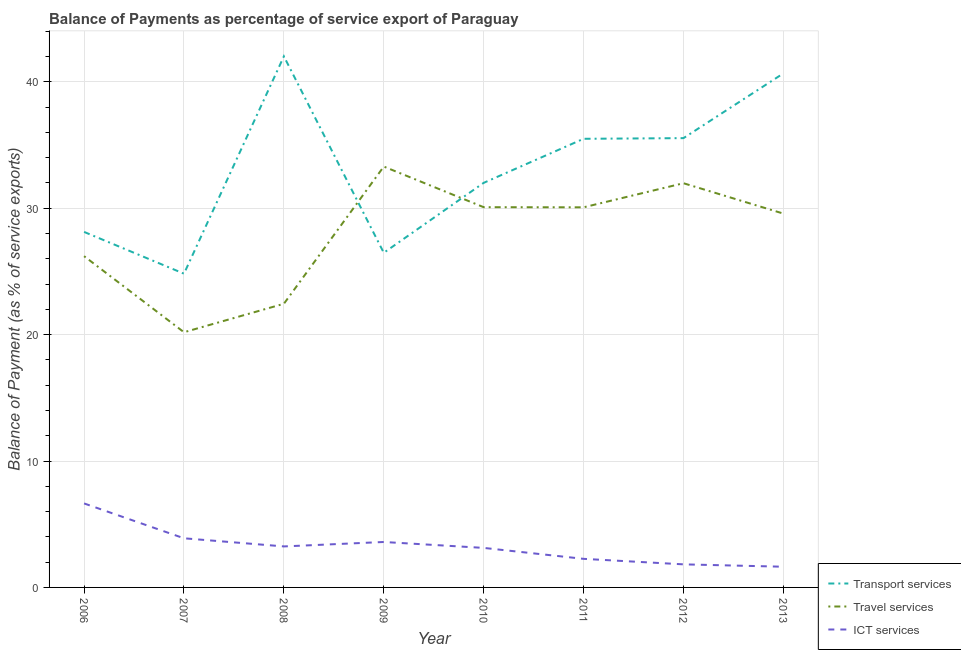Is the number of lines equal to the number of legend labels?
Make the answer very short. Yes. What is the balance of payment of ict services in 2011?
Ensure brevity in your answer.  2.26. Across all years, what is the maximum balance of payment of ict services?
Make the answer very short. 6.64. Across all years, what is the minimum balance of payment of travel services?
Your response must be concise. 20.19. What is the total balance of payment of ict services in the graph?
Your response must be concise. 26.22. What is the difference between the balance of payment of ict services in 2006 and that in 2011?
Your response must be concise. 4.38. What is the difference between the balance of payment of transport services in 2007 and the balance of payment of ict services in 2011?
Ensure brevity in your answer.  22.56. What is the average balance of payment of ict services per year?
Provide a short and direct response. 3.28. In the year 2010, what is the difference between the balance of payment of travel services and balance of payment of ict services?
Give a very brief answer. 26.96. In how many years, is the balance of payment of transport services greater than 10 %?
Your answer should be very brief. 8. What is the ratio of the balance of payment of ict services in 2012 to that in 2013?
Make the answer very short. 1.11. Is the balance of payment of ict services in 2008 less than that in 2010?
Give a very brief answer. No. What is the difference between the highest and the second highest balance of payment of travel services?
Your answer should be compact. 1.32. What is the difference between the highest and the lowest balance of payment of travel services?
Provide a succinct answer. 13.11. In how many years, is the balance of payment of transport services greater than the average balance of payment of transport services taken over all years?
Provide a succinct answer. 4. Is the sum of the balance of payment of ict services in 2008 and 2011 greater than the maximum balance of payment of travel services across all years?
Your answer should be compact. No. Is it the case that in every year, the sum of the balance of payment of transport services and balance of payment of travel services is greater than the balance of payment of ict services?
Offer a terse response. Yes. Does the balance of payment of travel services monotonically increase over the years?
Your answer should be compact. No. Does the graph contain any zero values?
Keep it short and to the point. No. What is the title of the graph?
Make the answer very short. Balance of Payments as percentage of service export of Paraguay. Does "Female employers" appear as one of the legend labels in the graph?
Offer a very short reply. No. What is the label or title of the X-axis?
Your response must be concise. Year. What is the label or title of the Y-axis?
Your answer should be compact. Balance of Payment (as % of service exports). What is the Balance of Payment (as % of service exports) of Transport services in 2006?
Offer a very short reply. 28.13. What is the Balance of Payment (as % of service exports) in Travel services in 2006?
Make the answer very short. 26.21. What is the Balance of Payment (as % of service exports) of ICT services in 2006?
Offer a terse response. 6.64. What is the Balance of Payment (as % of service exports) in Transport services in 2007?
Your response must be concise. 24.82. What is the Balance of Payment (as % of service exports) of Travel services in 2007?
Your response must be concise. 20.19. What is the Balance of Payment (as % of service exports) of ICT services in 2007?
Your answer should be compact. 3.89. What is the Balance of Payment (as % of service exports) of Transport services in 2008?
Keep it short and to the point. 42.02. What is the Balance of Payment (as % of service exports) in Travel services in 2008?
Keep it short and to the point. 22.44. What is the Balance of Payment (as % of service exports) in ICT services in 2008?
Your answer should be compact. 3.24. What is the Balance of Payment (as % of service exports) in Transport services in 2009?
Your answer should be compact. 26.48. What is the Balance of Payment (as % of service exports) of Travel services in 2009?
Provide a succinct answer. 33.3. What is the Balance of Payment (as % of service exports) in ICT services in 2009?
Give a very brief answer. 3.59. What is the Balance of Payment (as % of service exports) in Transport services in 2010?
Ensure brevity in your answer.  32.01. What is the Balance of Payment (as % of service exports) in Travel services in 2010?
Your answer should be very brief. 30.08. What is the Balance of Payment (as % of service exports) of ICT services in 2010?
Keep it short and to the point. 3.13. What is the Balance of Payment (as % of service exports) of Transport services in 2011?
Ensure brevity in your answer.  35.49. What is the Balance of Payment (as % of service exports) in Travel services in 2011?
Offer a terse response. 30.07. What is the Balance of Payment (as % of service exports) of ICT services in 2011?
Make the answer very short. 2.26. What is the Balance of Payment (as % of service exports) of Transport services in 2012?
Provide a succinct answer. 35.55. What is the Balance of Payment (as % of service exports) in Travel services in 2012?
Make the answer very short. 31.98. What is the Balance of Payment (as % of service exports) of ICT services in 2012?
Provide a short and direct response. 1.83. What is the Balance of Payment (as % of service exports) in Transport services in 2013?
Make the answer very short. 40.67. What is the Balance of Payment (as % of service exports) in Travel services in 2013?
Ensure brevity in your answer.  29.58. What is the Balance of Payment (as % of service exports) of ICT services in 2013?
Keep it short and to the point. 1.64. Across all years, what is the maximum Balance of Payment (as % of service exports) in Transport services?
Make the answer very short. 42.02. Across all years, what is the maximum Balance of Payment (as % of service exports) of Travel services?
Make the answer very short. 33.3. Across all years, what is the maximum Balance of Payment (as % of service exports) in ICT services?
Offer a very short reply. 6.64. Across all years, what is the minimum Balance of Payment (as % of service exports) of Transport services?
Make the answer very short. 24.82. Across all years, what is the minimum Balance of Payment (as % of service exports) in Travel services?
Your response must be concise. 20.19. Across all years, what is the minimum Balance of Payment (as % of service exports) in ICT services?
Keep it short and to the point. 1.64. What is the total Balance of Payment (as % of service exports) in Transport services in the graph?
Provide a succinct answer. 265.16. What is the total Balance of Payment (as % of service exports) in Travel services in the graph?
Provide a short and direct response. 223.85. What is the total Balance of Payment (as % of service exports) of ICT services in the graph?
Provide a short and direct response. 26.22. What is the difference between the Balance of Payment (as % of service exports) of Transport services in 2006 and that in 2007?
Ensure brevity in your answer.  3.31. What is the difference between the Balance of Payment (as % of service exports) in Travel services in 2006 and that in 2007?
Your response must be concise. 6.02. What is the difference between the Balance of Payment (as % of service exports) of ICT services in 2006 and that in 2007?
Ensure brevity in your answer.  2.76. What is the difference between the Balance of Payment (as % of service exports) in Transport services in 2006 and that in 2008?
Provide a succinct answer. -13.89. What is the difference between the Balance of Payment (as % of service exports) in Travel services in 2006 and that in 2008?
Keep it short and to the point. 3.77. What is the difference between the Balance of Payment (as % of service exports) of ICT services in 2006 and that in 2008?
Your answer should be very brief. 3.4. What is the difference between the Balance of Payment (as % of service exports) of Transport services in 2006 and that in 2009?
Give a very brief answer. 1.65. What is the difference between the Balance of Payment (as % of service exports) of Travel services in 2006 and that in 2009?
Your answer should be compact. -7.09. What is the difference between the Balance of Payment (as % of service exports) of ICT services in 2006 and that in 2009?
Provide a short and direct response. 3.05. What is the difference between the Balance of Payment (as % of service exports) of Transport services in 2006 and that in 2010?
Provide a succinct answer. -3.88. What is the difference between the Balance of Payment (as % of service exports) of Travel services in 2006 and that in 2010?
Provide a succinct answer. -3.88. What is the difference between the Balance of Payment (as % of service exports) of ICT services in 2006 and that in 2010?
Keep it short and to the point. 3.52. What is the difference between the Balance of Payment (as % of service exports) of Transport services in 2006 and that in 2011?
Provide a short and direct response. -7.37. What is the difference between the Balance of Payment (as % of service exports) of Travel services in 2006 and that in 2011?
Your response must be concise. -3.87. What is the difference between the Balance of Payment (as % of service exports) in ICT services in 2006 and that in 2011?
Provide a succinct answer. 4.38. What is the difference between the Balance of Payment (as % of service exports) of Transport services in 2006 and that in 2012?
Offer a very short reply. -7.42. What is the difference between the Balance of Payment (as % of service exports) in Travel services in 2006 and that in 2012?
Keep it short and to the point. -5.77. What is the difference between the Balance of Payment (as % of service exports) in ICT services in 2006 and that in 2012?
Your response must be concise. 4.82. What is the difference between the Balance of Payment (as % of service exports) in Transport services in 2006 and that in 2013?
Give a very brief answer. -12.54. What is the difference between the Balance of Payment (as % of service exports) of Travel services in 2006 and that in 2013?
Your answer should be compact. -3.37. What is the difference between the Balance of Payment (as % of service exports) in ICT services in 2006 and that in 2013?
Make the answer very short. 5.01. What is the difference between the Balance of Payment (as % of service exports) of Transport services in 2007 and that in 2008?
Ensure brevity in your answer.  -17.2. What is the difference between the Balance of Payment (as % of service exports) in Travel services in 2007 and that in 2008?
Ensure brevity in your answer.  -2.25. What is the difference between the Balance of Payment (as % of service exports) in ICT services in 2007 and that in 2008?
Your response must be concise. 0.64. What is the difference between the Balance of Payment (as % of service exports) in Transport services in 2007 and that in 2009?
Your answer should be very brief. -1.65. What is the difference between the Balance of Payment (as % of service exports) of Travel services in 2007 and that in 2009?
Your answer should be compact. -13.11. What is the difference between the Balance of Payment (as % of service exports) in ICT services in 2007 and that in 2009?
Keep it short and to the point. 0.29. What is the difference between the Balance of Payment (as % of service exports) in Transport services in 2007 and that in 2010?
Offer a very short reply. -7.19. What is the difference between the Balance of Payment (as % of service exports) in Travel services in 2007 and that in 2010?
Provide a succinct answer. -9.89. What is the difference between the Balance of Payment (as % of service exports) in ICT services in 2007 and that in 2010?
Your response must be concise. 0.76. What is the difference between the Balance of Payment (as % of service exports) of Transport services in 2007 and that in 2011?
Provide a succinct answer. -10.67. What is the difference between the Balance of Payment (as % of service exports) in Travel services in 2007 and that in 2011?
Provide a short and direct response. -9.88. What is the difference between the Balance of Payment (as % of service exports) in ICT services in 2007 and that in 2011?
Keep it short and to the point. 1.63. What is the difference between the Balance of Payment (as % of service exports) in Transport services in 2007 and that in 2012?
Keep it short and to the point. -10.72. What is the difference between the Balance of Payment (as % of service exports) in Travel services in 2007 and that in 2012?
Keep it short and to the point. -11.79. What is the difference between the Balance of Payment (as % of service exports) in ICT services in 2007 and that in 2012?
Give a very brief answer. 2.06. What is the difference between the Balance of Payment (as % of service exports) in Transport services in 2007 and that in 2013?
Make the answer very short. -15.85. What is the difference between the Balance of Payment (as % of service exports) in Travel services in 2007 and that in 2013?
Offer a terse response. -9.39. What is the difference between the Balance of Payment (as % of service exports) in ICT services in 2007 and that in 2013?
Provide a short and direct response. 2.25. What is the difference between the Balance of Payment (as % of service exports) of Transport services in 2008 and that in 2009?
Make the answer very short. 15.54. What is the difference between the Balance of Payment (as % of service exports) in Travel services in 2008 and that in 2009?
Your answer should be very brief. -10.86. What is the difference between the Balance of Payment (as % of service exports) in ICT services in 2008 and that in 2009?
Offer a terse response. -0.35. What is the difference between the Balance of Payment (as % of service exports) of Transport services in 2008 and that in 2010?
Your answer should be compact. 10.01. What is the difference between the Balance of Payment (as % of service exports) of Travel services in 2008 and that in 2010?
Your response must be concise. -7.64. What is the difference between the Balance of Payment (as % of service exports) in ICT services in 2008 and that in 2010?
Keep it short and to the point. 0.12. What is the difference between the Balance of Payment (as % of service exports) of Transport services in 2008 and that in 2011?
Provide a succinct answer. 6.52. What is the difference between the Balance of Payment (as % of service exports) in Travel services in 2008 and that in 2011?
Offer a terse response. -7.63. What is the difference between the Balance of Payment (as % of service exports) of ICT services in 2008 and that in 2011?
Your response must be concise. 0.98. What is the difference between the Balance of Payment (as % of service exports) of Transport services in 2008 and that in 2012?
Provide a short and direct response. 6.47. What is the difference between the Balance of Payment (as % of service exports) in Travel services in 2008 and that in 2012?
Ensure brevity in your answer.  -9.54. What is the difference between the Balance of Payment (as % of service exports) of ICT services in 2008 and that in 2012?
Keep it short and to the point. 1.42. What is the difference between the Balance of Payment (as % of service exports) of Transport services in 2008 and that in 2013?
Keep it short and to the point. 1.35. What is the difference between the Balance of Payment (as % of service exports) of Travel services in 2008 and that in 2013?
Offer a terse response. -7.13. What is the difference between the Balance of Payment (as % of service exports) in ICT services in 2008 and that in 2013?
Ensure brevity in your answer.  1.61. What is the difference between the Balance of Payment (as % of service exports) of Transport services in 2009 and that in 2010?
Provide a short and direct response. -5.53. What is the difference between the Balance of Payment (as % of service exports) of Travel services in 2009 and that in 2010?
Provide a short and direct response. 3.21. What is the difference between the Balance of Payment (as % of service exports) in ICT services in 2009 and that in 2010?
Keep it short and to the point. 0.47. What is the difference between the Balance of Payment (as % of service exports) in Transport services in 2009 and that in 2011?
Provide a short and direct response. -9.02. What is the difference between the Balance of Payment (as % of service exports) of Travel services in 2009 and that in 2011?
Your answer should be very brief. 3.23. What is the difference between the Balance of Payment (as % of service exports) in ICT services in 2009 and that in 2011?
Your response must be concise. 1.33. What is the difference between the Balance of Payment (as % of service exports) in Transport services in 2009 and that in 2012?
Provide a short and direct response. -9.07. What is the difference between the Balance of Payment (as % of service exports) in Travel services in 2009 and that in 2012?
Ensure brevity in your answer.  1.32. What is the difference between the Balance of Payment (as % of service exports) of ICT services in 2009 and that in 2012?
Your answer should be very brief. 1.77. What is the difference between the Balance of Payment (as % of service exports) in Transport services in 2009 and that in 2013?
Ensure brevity in your answer.  -14.19. What is the difference between the Balance of Payment (as % of service exports) of Travel services in 2009 and that in 2013?
Your response must be concise. 3.72. What is the difference between the Balance of Payment (as % of service exports) of ICT services in 2009 and that in 2013?
Your response must be concise. 1.96. What is the difference between the Balance of Payment (as % of service exports) of Transport services in 2010 and that in 2011?
Give a very brief answer. -3.49. What is the difference between the Balance of Payment (as % of service exports) of Travel services in 2010 and that in 2011?
Give a very brief answer. 0.01. What is the difference between the Balance of Payment (as % of service exports) in ICT services in 2010 and that in 2011?
Keep it short and to the point. 0.87. What is the difference between the Balance of Payment (as % of service exports) of Transport services in 2010 and that in 2012?
Your answer should be very brief. -3.54. What is the difference between the Balance of Payment (as % of service exports) of Travel services in 2010 and that in 2012?
Your answer should be very brief. -1.9. What is the difference between the Balance of Payment (as % of service exports) of ICT services in 2010 and that in 2012?
Your answer should be very brief. 1.3. What is the difference between the Balance of Payment (as % of service exports) of Transport services in 2010 and that in 2013?
Your answer should be compact. -8.66. What is the difference between the Balance of Payment (as % of service exports) of Travel services in 2010 and that in 2013?
Offer a very short reply. 0.51. What is the difference between the Balance of Payment (as % of service exports) of ICT services in 2010 and that in 2013?
Ensure brevity in your answer.  1.49. What is the difference between the Balance of Payment (as % of service exports) in Transport services in 2011 and that in 2012?
Provide a short and direct response. -0.05. What is the difference between the Balance of Payment (as % of service exports) of Travel services in 2011 and that in 2012?
Give a very brief answer. -1.91. What is the difference between the Balance of Payment (as % of service exports) of ICT services in 2011 and that in 2012?
Ensure brevity in your answer.  0.44. What is the difference between the Balance of Payment (as % of service exports) in Transport services in 2011 and that in 2013?
Provide a succinct answer. -5.17. What is the difference between the Balance of Payment (as % of service exports) of Travel services in 2011 and that in 2013?
Your response must be concise. 0.5. What is the difference between the Balance of Payment (as % of service exports) in ICT services in 2011 and that in 2013?
Your response must be concise. 0.62. What is the difference between the Balance of Payment (as % of service exports) of Transport services in 2012 and that in 2013?
Offer a terse response. -5.12. What is the difference between the Balance of Payment (as % of service exports) in Travel services in 2012 and that in 2013?
Keep it short and to the point. 2.4. What is the difference between the Balance of Payment (as % of service exports) of ICT services in 2012 and that in 2013?
Offer a very short reply. 0.19. What is the difference between the Balance of Payment (as % of service exports) of Transport services in 2006 and the Balance of Payment (as % of service exports) of Travel services in 2007?
Provide a short and direct response. 7.94. What is the difference between the Balance of Payment (as % of service exports) of Transport services in 2006 and the Balance of Payment (as % of service exports) of ICT services in 2007?
Give a very brief answer. 24.24. What is the difference between the Balance of Payment (as % of service exports) in Travel services in 2006 and the Balance of Payment (as % of service exports) in ICT services in 2007?
Ensure brevity in your answer.  22.32. What is the difference between the Balance of Payment (as % of service exports) in Transport services in 2006 and the Balance of Payment (as % of service exports) in Travel services in 2008?
Ensure brevity in your answer.  5.69. What is the difference between the Balance of Payment (as % of service exports) in Transport services in 2006 and the Balance of Payment (as % of service exports) in ICT services in 2008?
Make the answer very short. 24.88. What is the difference between the Balance of Payment (as % of service exports) in Travel services in 2006 and the Balance of Payment (as % of service exports) in ICT services in 2008?
Your answer should be compact. 22.96. What is the difference between the Balance of Payment (as % of service exports) in Transport services in 2006 and the Balance of Payment (as % of service exports) in Travel services in 2009?
Your answer should be compact. -5.17. What is the difference between the Balance of Payment (as % of service exports) in Transport services in 2006 and the Balance of Payment (as % of service exports) in ICT services in 2009?
Your response must be concise. 24.53. What is the difference between the Balance of Payment (as % of service exports) in Travel services in 2006 and the Balance of Payment (as % of service exports) in ICT services in 2009?
Your response must be concise. 22.61. What is the difference between the Balance of Payment (as % of service exports) of Transport services in 2006 and the Balance of Payment (as % of service exports) of Travel services in 2010?
Keep it short and to the point. -1.96. What is the difference between the Balance of Payment (as % of service exports) in Transport services in 2006 and the Balance of Payment (as % of service exports) in ICT services in 2010?
Your answer should be compact. 25. What is the difference between the Balance of Payment (as % of service exports) of Travel services in 2006 and the Balance of Payment (as % of service exports) of ICT services in 2010?
Make the answer very short. 23.08. What is the difference between the Balance of Payment (as % of service exports) of Transport services in 2006 and the Balance of Payment (as % of service exports) of Travel services in 2011?
Keep it short and to the point. -1.95. What is the difference between the Balance of Payment (as % of service exports) in Transport services in 2006 and the Balance of Payment (as % of service exports) in ICT services in 2011?
Your answer should be very brief. 25.87. What is the difference between the Balance of Payment (as % of service exports) in Travel services in 2006 and the Balance of Payment (as % of service exports) in ICT services in 2011?
Offer a very short reply. 23.95. What is the difference between the Balance of Payment (as % of service exports) in Transport services in 2006 and the Balance of Payment (as % of service exports) in Travel services in 2012?
Provide a short and direct response. -3.85. What is the difference between the Balance of Payment (as % of service exports) in Transport services in 2006 and the Balance of Payment (as % of service exports) in ICT services in 2012?
Offer a terse response. 26.3. What is the difference between the Balance of Payment (as % of service exports) in Travel services in 2006 and the Balance of Payment (as % of service exports) in ICT services in 2012?
Offer a very short reply. 24.38. What is the difference between the Balance of Payment (as % of service exports) of Transport services in 2006 and the Balance of Payment (as % of service exports) of Travel services in 2013?
Your response must be concise. -1.45. What is the difference between the Balance of Payment (as % of service exports) of Transport services in 2006 and the Balance of Payment (as % of service exports) of ICT services in 2013?
Provide a succinct answer. 26.49. What is the difference between the Balance of Payment (as % of service exports) in Travel services in 2006 and the Balance of Payment (as % of service exports) in ICT services in 2013?
Your answer should be very brief. 24.57. What is the difference between the Balance of Payment (as % of service exports) in Transport services in 2007 and the Balance of Payment (as % of service exports) in Travel services in 2008?
Give a very brief answer. 2.38. What is the difference between the Balance of Payment (as % of service exports) in Transport services in 2007 and the Balance of Payment (as % of service exports) in ICT services in 2008?
Keep it short and to the point. 21.58. What is the difference between the Balance of Payment (as % of service exports) of Travel services in 2007 and the Balance of Payment (as % of service exports) of ICT services in 2008?
Keep it short and to the point. 16.95. What is the difference between the Balance of Payment (as % of service exports) of Transport services in 2007 and the Balance of Payment (as % of service exports) of Travel services in 2009?
Your answer should be very brief. -8.48. What is the difference between the Balance of Payment (as % of service exports) in Transport services in 2007 and the Balance of Payment (as % of service exports) in ICT services in 2009?
Offer a terse response. 21.23. What is the difference between the Balance of Payment (as % of service exports) in Travel services in 2007 and the Balance of Payment (as % of service exports) in ICT services in 2009?
Give a very brief answer. 16.6. What is the difference between the Balance of Payment (as % of service exports) of Transport services in 2007 and the Balance of Payment (as % of service exports) of Travel services in 2010?
Make the answer very short. -5.26. What is the difference between the Balance of Payment (as % of service exports) in Transport services in 2007 and the Balance of Payment (as % of service exports) in ICT services in 2010?
Make the answer very short. 21.69. What is the difference between the Balance of Payment (as % of service exports) of Travel services in 2007 and the Balance of Payment (as % of service exports) of ICT services in 2010?
Your response must be concise. 17.06. What is the difference between the Balance of Payment (as % of service exports) of Transport services in 2007 and the Balance of Payment (as % of service exports) of Travel services in 2011?
Keep it short and to the point. -5.25. What is the difference between the Balance of Payment (as % of service exports) in Transport services in 2007 and the Balance of Payment (as % of service exports) in ICT services in 2011?
Your answer should be very brief. 22.56. What is the difference between the Balance of Payment (as % of service exports) in Travel services in 2007 and the Balance of Payment (as % of service exports) in ICT services in 2011?
Your answer should be very brief. 17.93. What is the difference between the Balance of Payment (as % of service exports) in Transport services in 2007 and the Balance of Payment (as % of service exports) in Travel services in 2012?
Provide a succinct answer. -7.16. What is the difference between the Balance of Payment (as % of service exports) in Transport services in 2007 and the Balance of Payment (as % of service exports) in ICT services in 2012?
Offer a very short reply. 23. What is the difference between the Balance of Payment (as % of service exports) in Travel services in 2007 and the Balance of Payment (as % of service exports) in ICT services in 2012?
Keep it short and to the point. 18.36. What is the difference between the Balance of Payment (as % of service exports) of Transport services in 2007 and the Balance of Payment (as % of service exports) of Travel services in 2013?
Make the answer very short. -4.75. What is the difference between the Balance of Payment (as % of service exports) of Transport services in 2007 and the Balance of Payment (as % of service exports) of ICT services in 2013?
Provide a short and direct response. 23.18. What is the difference between the Balance of Payment (as % of service exports) of Travel services in 2007 and the Balance of Payment (as % of service exports) of ICT services in 2013?
Your response must be concise. 18.55. What is the difference between the Balance of Payment (as % of service exports) in Transport services in 2008 and the Balance of Payment (as % of service exports) in Travel services in 2009?
Offer a very short reply. 8.72. What is the difference between the Balance of Payment (as % of service exports) in Transport services in 2008 and the Balance of Payment (as % of service exports) in ICT services in 2009?
Your answer should be very brief. 38.42. What is the difference between the Balance of Payment (as % of service exports) in Travel services in 2008 and the Balance of Payment (as % of service exports) in ICT services in 2009?
Keep it short and to the point. 18.85. What is the difference between the Balance of Payment (as % of service exports) of Transport services in 2008 and the Balance of Payment (as % of service exports) of Travel services in 2010?
Give a very brief answer. 11.93. What is the difference between the Balance of Payment (as % of service exports) of Transport services in 2008 and the Balance of Payment (as % of service exports) of ICT services in 2010?
Offer a terse response. 38.89. What is the difference between the Balance of Payment (as % of service exports) in Travel services in 2008 and the Balance of Payment (as % of service exports) in ICT services in 2010?
Ensure brevity in your answer.  19.31. What is the difference between the Balance of Payment (as % of service exports) of Transport services in 2008 and the Balance of Payment (as % of service exports) of Travel services in 2011?
Provide a short and direct response. 11.94. What is the difference between the Balance of Payment (as % of service exports) in Transport services in 2008 and the Balance of Payment (as % of service exports) in ICT services in 2011?
Keep it short and to the point. 39.76. What is the difference between the Balance of Payment (as % of service exports) of Travel services in 2008 and the Balance of Payment (as % of service exports) of ICT services in 2011?
Give a very brief answer. 20.18. What is the difference between the Balance of Payment (as % of service exports) in Transport services in 2008 and the Balance of Payment (as % of service exports) in Travel services in 2012?
Provide a short and direct response. 10.04. What is the difference between the Balance of Payment (as % of service exports) of Transport services in 2008 and the Balance of Payment (as % of service exports) of ICT services in 2012?
Your response must be concise. 40.19. What is the difference between the Balance of Payment (as % of service exports) in Travel services in 2008 and the Balance of Payment (as % of service exports) in ICT services in 2012?
Keep it short and to the point. 20.62. What is the difference between the Balance of Payment (as % of service exports) in Transport services in 2008 and the Balance of Payment (as % of service exports) in Travel services in 2013?
Keep it short and to the point. 12.44. What is the difference between the Balance of Payment (as % of service exports) of Transport services in 2008 and the Balance of Payment (as % of service exports) of ICT services in 2013?
Your answer should be compact. 40.38. What is the difference between the Balance of Payment (as % of service exports) of Travel services in 2008 and the Balance of Payment (as % of service exports) of ICT services in 2013?
Keep it short and to the point. 20.8. What is the difference between the Balance of Payment (as % of service exports) in Transport services in 2009 and the Balance of Payment (as % of service exports) in Travel services in 2010?
Offer a terse response. -3.61. What is the difference between the Balance of Payment (as % of service exports) in Transport services in 2009 and the Balance of Payment (as % of service exports) in ICT services in 2010?
Provide a succinct answer. 23.35. What is the difference between the Balance of Payment (as % of service exports) of Travel services in 2009 and the Balance of Payment (as % of service exports) of ICT services in 2010?
Your answer should be compact. 30.17. What is the difference between the Balance of Payment (as % of service exports) in Transport services in 2009 and the Balance of Payment (as % of service exports) in Travel services in 2011?
Your answer should be compact. -3.6. What is the difference between the Balance of Payment (as % of service exports) of Transport services in 2009 and the Balance of Payment (as % of service exports) of ICT services in 2011?
Keep it short and to the point. 24.21. What is the difference between the Balance of Payment (as % of service exports) in Travel services in 2009 and the Balance of Payment (as % of service exports) in ICT services in 2011?
Your response must be concise. 31.04. What is the difference between the Balance of Payment (as % of service exports) of Transport services in 2009 and the Balance of Payment (as % of service exports) of Travel services in 2012?
Make the answer very short. -5.5. What is the difference between the Balance of Payment (as % of service exports) in Transport services in 2009 and the Balance of Payment (as % of service exports) in ICT services in 2012?
Offer a terse response. 24.65. What is the difference between the Balance of Payment (as % of service exports) in Travel services in 2009 and the Balance of Payment (as % of service exports) in ICT services in 2012?
Offer a very short reply. 31.47. What is the difference between the Balance of Payment (as % of service exports) of Transport services in 2009 and the Balance of Payment (as % of service exports) of Travel services in 2013?
Provide a succinct answer. -3.1. What is the difference between the Balance of Payment (as % of service exports) in Transport services in 2009 and the Balance of Payment (as % of service exports) in ICT services in 2013?
Provide a short and direct response. 24.84. What is the difference between the Balance of Payment (as % of service exports) in Travel services in 2009 and the Balance of Payment (as % of service exports) in ICT services in 2013?
Ensure brevity in your answer.  31.66. What is the difference between the Balance of Payment (as % of service exports) in Transport services in 2010 and the Balance of Payment (as % of service exports) in Travel services in 2011?
Your answer should be compact. 1.94. What is the difference between the Balance of Payment (as % of service exports) in Transport services in 2010 and the Balance of Payment (as % of service exports) in ICT services in 2011?
Ensure brevity in your answer.  29.75. What is the difference between the Balance of Payment (as % of service exports) of Travel services in 2010 and the Balance of Payment (as % of service exports) of ICT services in 2011?
Ensure brevity in your answer.  27.82. What is the difference between the Balance of Payment (as % of service exports) in Transport services in 2010 and the Balance of Payment (as % of service exports) in ICT services in 2012?
Keep it short and to the point. 30.18. What is the difference between the Balance of Payment (as % of service exports) of Travel services in 2010 and the Balance of Payment (as % of service exports) of ICT services in 2012?
Your response must be concise. 28.26. What is the difference between the Balance of Payment (as % of service exports) of Transport services in 2010 and the Balance of Payment (as % of service exports) of Travel services in 2013?
Your answer should be compact. 2.43. What is the difference between the Balance of Payment (as % of service exports) in Transport services in 2010 and the Balance of Payment (as % of service exports) in ICT services in 2013?
Make the answer very short. 30.37. What is the difference between the Balance of Payment (as % of service exports) of Travel services in 2010 and the Balance of Payment (as % of service exports) of ICT services in 2013?
Provide a succinct answer. 28.45. What is the difference between the Balance of Payment (as % of service exports) in Transport services in 2011 and the Balance of Payment (as % of service exports) in Travel services in 2012?
Keep it short and to the point. 3.52. What is the difference between the Balance of Payment (as % of service exports) of Transport services in 2011 and the Balance of Payment (as % of service exports) of ICT services in 2012?
Provide a succinct answer. 33.67. What is the difference between the Balance of Payment (as % of service exports) of Travel services in 2011 and the Balance of Payment (as % of service exports) of ICT services in 2012?
Your response must be concise. 28.25. What is the difference between the Balance of Payment (as % of service exports) of Transport services in 2011 and the Balance of Payment (as % of service exports) of Travel services in 2013?
Keep it short and to the point. 5.92. What is the difference between the Balance of Payment (as % of service exports) of Transport services in 2011 and the Balance of Payment (as % of service exports) of ICT services in 2013?
Your response must be concise. 33.86. What is the difference between the Balance of Payment (as % of service exports) of Travel services in 2011 and the Balance of Payment (as % of service exports) of ICT services in 2013?
Give a very brief answer. 28.43. What is the difference between the Balance of Payment (as % of service exports) in Transport services in 2012 and the Balance of Payment (as % of service exports) in Travel services in 2013?
Provide a succinct answer. 5.97. What is the difference between the Balance of Payment (as % of service exports) of Transport services in 2012 and the Balance of Payment (as % of service exports) of ICT services in 2013?
Give a very brief answer. 33.91. What is the difference between the Balance of Payment (as % of service exports) of Travel services in 2012 and the Balance of Payment (as % of service exports) of ICT services in 2013?
Your response must be concise. 30.34. What is the average Balance of Payment (as % of service exports) in Transport services per year?
Give a very brief answer. 33.14. What is the average Balance of Payment (as % of service exports) in Travel services per year?
Offer a very short reply. 27.98. What is the average Balance of Payment (as % of service exports) in ICT services per year?
Make the answer very short. 3.28. In the year 2006, what is the difference between the Balance of Payment (as % of service exports) in Transport services and Balance of Payment (as % of service exports) in Travel services?
Make the answer very short. 1.92. In the year 2006, what is the difference between the Balance of Payment (as % of service exports) in Transport services and Balance of Payment (as % of service exports) in ICT services?
Provide a short and direct response. 21.48. In the year 2006, what is the difference between the Balance of Payment (as % of service exports) of Travel services and Balance of Payment (as % of service exports) of ICT services?
Offer a terse response. 19.56. In the year 2007, what is the difference between the Balance of Payment (as % of service exports) in Transport services and Balance of Payment (as % of service exports) in Travel services?
Offer a very short reply. 4.63. In the year 2007, what is the difference between the Balance of Payment (as % of service exports) of Transport services and Balance of Payment (as % of service exports) of ICT services?
Offer a terse response. 20.93. In the year 2007, what is the difference between the Balance of Payment (as % of service exports) in Travel services and Balance of Payment (as % of service exports) in ICT services?
Give a very brief answer. 16.3. In the year 2008, what is the difference between the Balance of Payment (as % of service exports) in Transport services and Balance of Payment (as % of service exports) in Travel services?
Make the answer very short. 19.58. In the year 2008, what is the difference between the Balance of Payment (as % of service exports) in Transport services and Balance of Payment (as % of service exports) in ICT services?
Offer a terse response. 38.77. In the year 2008, what is the difference between the Balance of Payment (as % of service exports) in Travel services and Balance of Payment (as % of service exports) in ICT services?
Keep it short and to the point. 19.2. In the year 2009, what is the difference between the Balance of Payment (as % of service exports) in Transport services and Balance of Payment (as % of service exports) in Travel services?
Give a very brief answer. -6.82. In the year 2009, what is the difference between the Balance of Payment (as % of service exports) of Transport services and Balance of Payment (as % of service exports) of ICT services?
Your response must be concise. 22.88. In the year 2009, what is the difference between the Balance of Payment (as % of service exports) in Travel services and Balance of Payment (as % of service exports) in ICT services?
Make the answer very short. 29.7. In the year 2010, what is the difference between the Balance of Payment (as % of service exports) of Transport services and Balance of Payment (as % of service exports) of Travel services?
Keep it short and to the point. 1.93. In the year 2010, what is the difference between the Balance of Payment (as % of service exports) in Transport services and Balance of Payment (as % of service exports) in ICT services?
Your answer should be very brief. 28.88. In the year 2010, what is the difference between the Balance of Payment (as % of service exports) in Travel services and Balance of Payment (as % of service exports) in ICT services?
Your answer should be compact. 26.96. In the year 2011, what is the difference between the Balance of Payment (as % of service exports) in Transport services and Balance of Payment (as % of service exports) in Travel services?
Provide a succinct answer. 5.42. In the year 2011, what is the difference between the Balance of Payment (as % of service exports) in Transport services and Balance of Payment (as % of service exports) in ICT services?
Provide a short and direct response. 33.23. In the year 2011, what is the difference between the Balance of Payment (as % of service exports) in Travel services and Balance of Payment (as % of service exports) in ICT services?
Ensure brevity in your answer.  27.81. In the year 2012, what is the difference between the Balance of Payment (as % of service exports) of Transport services and Balance of Payment (as % of service exports) of Travel services?
Ensure brevity in your answer.  3.57. In the year 2012, what is the difference between the Balance of Payment (as % of service exports) in Transport services and Balance of Payment (as % of service exports) in ICT services?
Provide a succinct answer. 33.72. In the year 2012, what is the difference between the Balance of Payment (as % of service exports) in Travel services and Balance of Payment (as % of service exports) in ICT services?
Give a very brief answer. 30.15. In the year 2013, what is the difference between the Balance of Payment (as % of service exports) of Transport services and Balance of Payment (as % of service exports) of Travel services?
Make the answer very short. 11.09. In the year 2013, what is the difference between the Balance of Payment (as % of service exports) in Transport services and Balance of Payment (as % of service exports) in ICT services?
Offer a terse response. 39.03. In the year 2013, what is the difference between the Balance of Payment (as % of service exports) in Travel services and Balance of Payment (as % of service exports) in ICT services?
Give a very brief answer. 27.94. What is the ratio of the Balance of Payment (as % of service exports) in Transport services in 2006 to that in 2007?
Keep it short and to the point. 1.13. What is the ratio of the Balance of Payment (as % of service exports) of Travel services in 2006 to that in 2007?
Give a very brief answer. 1.3. What is the ratio of the Balance of Payment (as % of service exports) of ICT services in 2006 to that in 2007?
Provide a short and direct response. 1.71. What is the ratio of the Balance of Payment (as % of service exports) of Transport services in 2006 to that in 2008?
Provide a short and direct response. 0.67. What is the ratio of the Balance of Payment (as % of service exports) in Travel services in 2006 to that in 2008?
Your response must be concise. 1.17. What is the ratio of the Balance of Payment (as % of service exports) of ICT services in 2006 to that in 2008?
Ensure brevity in your answer.  2.05. What is the ratio of the Balance of Payment (as % of service exports) in Transport services in 2006 to that in 2009?
Make the answer very short. 1.06. What is the ratio of the Balance of Payment (as % of service exports) of Travel services in 2006 to that in 2009?
Make the answer very short. 0.79. What is the ratio of the Balance of Payment (as % of service exports) in ICT services in 2006 to that in 2009?
Provide a short and direct response. 1.85. What is the ratio of the Balance of Payment (as % of service exports) in Transport services in 2006 to that in 2010?
Make the answer very short. 0.88. What is the ratio of the Balance of Payment (as % of service exports) of Travel services in 2006 to that in 2010?
Give a very brief answer. 0.87. What is the ratio of the Balance of Payment (as % of service exports) in ICT services in 2006 to that in 2010?
Ensure brevity in your answer.  2.12. What is the ratio of the Balance of Payment (as % of service exports) in Transport services in 2006 to that in 2011?
Make the answer very short. 0.79. What is the ratio of the Balance of Payment (as % of service exports) of Travel services in 2006 to that in 2011?
Provide a short and direct response. 0.87. What is the ratio of the Balance of Payment (as % of service exports) of ICT services in 2006 to that in 2011?
Ensure brevity in your answer.  2.94. What is the ratio of the Balance of Payment (as % of service exports) in Transport services in 2006 to that in 2012?
Your answer should be very brief. 0.79. What is the ratio of the Balance of Payment (as % of service exports) of Travel services in 2006 to that in 2012?
Offer a terse response. 0.82. What is the ratio of the Balance of Payment (as % of service exports) in ICT services in 2006 to that in 2012?
Make the answer very short. 3.64. What is the ratio of the Balance of Payment (as % of service exports) in Transport services in 2006 to that in 2013?
Give a very brief answer. 0.69. What is the ratio of the Balance of Payment (as % of service exports) in Travel services in 2006 to that in 2013?
Provide a short and direct response. 0.89. What is the ratio of the Balance of Payment (as % of service exports) in ICT services in 2006 to that in 2013?
Offer a terse response. 4.06. What is the ratio of the Balance of Payment (as % of service exports) in Transport services in 2007 to that in 2008?
Your answer should be very brief. 0.59. What is the ratio of the Balance of Payment (as % of service exports) in Travel services in 2007 to that in 2008?
Ensure brevity in your answer.  0.9. What is the ratio of the Balance of Payment (as % of service exports) of ICT services in 2007 to that in 2008?
Ensure brevity in your answer.  1.2. What is the ratio of the Balance of Payment (as % of service exports) of Transport services in 2007 to that in 2009?
Give a very brief answer. 0.94. What is the ratio of the Balance of Payment (as % of service exports) of Travel services in 2007 to that in 2009?
Provide a short and direct response. 0.61. What is the ratio of the Balance of Payment (as % of service exports) of ICT services in 2007 to that in 2009?
Make the answer very short. 1.08. What is the ratio of the Balance of Payment (as % of service exports) of Transport services in 2007 to that in 2010?
Your answer should be compact. 0.78. What is the ratio of the Balance of Payment (as % of service exports) of Travel services in 2007 to that in 2010?
Provide a short and direct response. 0.67. What is the ratio of the Balance of Payment (as % of service exports) of ICT services in 2007 to that in 2010?
Make the answer very short. 1.24. What is the ratio of the Balance of Payment (as % of service exports) in Transport services in 2007 to that in 2011?
Give a very brief answer. 0.7. What is the ratio of the Balance of Payment (as % of service exports) in Travel services in 2007 to that in 2011?
Your answer should be very brief. 0.67. What is the ratio of the Balance of Payment (as % of service exports) in ICT services in 2007 to that in 2011?
Keep it short and to the point. 1.72. What is the ratio of the Balance of Payment (as % of service exports) in Transport services in 2007 to that in 2012?
Your answer should be very brief. 0.7. What is the ratio of the Balance of Payment (as % of service exports) in Travel services in 2007 to that in 2012?
Provide a short and direct response. 0.63. What is the ratio of the Balance of Payment (as % of service exports) in ICT services in 2007 to that in 2012?
Give a very brief answer. 2.13. What is the ratio of the Balance of Payment (as % of service exports) of Transport services in 2007 to that in 2013?
Offer a very short reply. 0.61. What is the ratio of the Balance of Payment (as % of service exports) of Travel services in 2007 to that in 2013?
Give a very brief answer. 0.68. What is the ratio of the Balance of Payment (as % of service exports) of ICT services in 2007 to that in 2013?
Your answer should be compact. 2.37. What is the ratio of the Balance of Payment (as % of service exports) of Transport services in 2008 to that in 2009?
Offer a terse response. 1.59. What is the ratio of the Balance of Payment (as % of service exports) in Travel services in 2008 to that in 2009?
Your answer should be compact. 0.67. What is the ratio of the Balance of Payment (as % of service exports) in ICT services in 2008 to that in 2009?
Provide a short and direct response. 0.9. What is the ratio of the Balance of Payment (as % of service exports) of Transport services in 2008 to that in 2010?
Your answer should be compact. 1.31. What is the ratio of the Balance of Payment (as % of service exports) of Travel services in 2008 to that in 2010?
Keep it short and to the point. 0.75. What is the ratio of the Balance of Payment (as % of service exports) of ICT services in 2008 to that in 2010?
Provide a short and direct response. 1.04. What is the ratio of the Balance of Payment (as % of service exports) in Transport services in 2008 to that in 2011?
Keep it short and to the point. 1.18. What is the ratio of the Balance of Payment (as % of service exports) in Travel services in 2008 to that in 2011?
Your answer should be compact. 0.75. What is the ratio of the Balance of Payment (as % of service exports) of ICT services in 2008 to that in 2011?
Your answer should be compact. 1.43. What is the ratio of the Balance of Payment (as % of service exports) of Transport services in 2008 to that in 2012?
Give a very brief answer. 1.18. What is the ratio of the Balance of Payment (as % of service exports) of Travel services in 2008 to that in 2012?
Make the answer very short. 0.7. What is the ratio of the Balance of Payment (as % of service exports) in ICT services in 2008 to that in 2012?
Give a very brief answer. 1.78. What is the ratio of the Balance of Payment (as % of service exports) in Transport services in 2008 to that in 2013?
Your answer should be very brief. 1.03. What is the ratio of the Balance of Payment (as % of service exports) of Travel services in 2008 to that in 2013?
Offer a very short reply. 0.76. What is the ratio of the Balance of Payment (as % of service exports) in ICT services in 2008 to that in 2013?
Your response must be concise. 1.98. What is the ratio of the Balance of Payment (as % of service exports) in Transport services in 2009 to that in 2010?
Make the answer very short. 0.83. What is the ratio of the Balance of Payment (as % of service exports) of Travel services in 2009 to that in 2010?
Make the answer very short. 1.11. What is the ratio of the Balance of Payment (as % of service exports) in ICT services in 2009 to that in 2010?
Provide a succinct answer. 1.15. What is the ratio of the Balance of Payment (as % of service exports) in Transport services in 2009 to that in 2011?
Give a very brief answer. 0.75. What is the ratio of the Balance of Payment (as % of service exports) of Travel services in 2009 to that in 2011?
Keep it short and to the point. 1.11. What is the ratio of the Balance of Payment (as % of service exports) of ICT services in 2009 to that in 2011?
Your answer should be compact. 1.59. What is the ratio of the Balance of Payment (as % of service exports) in Transport services in 2009 to that in 2012?
Your response must be concise. 0.74. What is the ratio of the Balance of Payment (as % of service exports) of Travel services in 2009 to that in 2012?
Provide a succinct answer. 1.04. What is the ratio of the Balance of Payment (as % of service exports) of ICT services in 2009 to that in 2012?
Offer a terse response. 1.97. What is the ratio of the Balance of Payment (as % of service exports) of Transport services in 2009 to that in 2013?
Give a very brief answer. 0.65. What is the ratio of the Balance of Payment (as % of service exports) in Travel services in 2009 to that in 2013?
Offer a terse response. 1.13. What is the ratio of the Balance of Payment (as % of service exports) in ICT services in 2009 to that in 2013?
Offer a terse response. 2.2. What is the ratio of the Balance of Payment (as % of service exports) in Transport services in 2010 to that in 2011?
Provide a succinct answer. 0.9. What is the ratio of the Balance of Payment (as % of service exports) of Travel services in 2010 to that in 2011?
Provide a succinct answer. 1. What is the ratio of the Balance of Payment (as % of service exports) of ICT services in 2010 to that in 2011?
Provide a succinct answer. 1.38. What is the ratio of the Balance of Payment (as % of service exports) of Transport services in 2010 to that in 2012?
Provide a short and direct response. 0.9. What is the ratio of the Balance of Payment (as % of service exports) of Travel services in 2010 to that in 2012?
Ensure brevity in your answer.  0.94. What is the ratio of the Balance of Payment (as % of service exports) of ICT services in 2010 to that in 2012?
Provide a short and direct response. 1.71. What is the ratio of the Balance of Payment (as % of service exports) of Transport services in 2010 to that in 2013?
Your answer should be compact. 0.79. What is the ratio of the Balance of Payment (as % of service exports) of Travel services in 2010 to that in 2013?
Provide a succinct answer. 1.02. What is the ratio of the Balance of Payment (as % of service exports) of ICT services in 2010 to that in 2013?
Offer a terse response. 1.91. What is the ratio of the Balance of Payment (as % of service exports) of Transport services in 2011 to that in 2012?
Provide a succinct answer. 1. What is the ratio of the Balance of Payment (as % of service exports) in Travel services in 2011 to that in 2012?
Ensure brevity in your answer.  0.94. What is the ratio of the Balance of Payment (as % of service exports) of ICT services in 2011 to that in 2012?
Make the answer very short. 1.24. What is the ratio of the Balance of Payment (as % of service exports) in Transport services in 2011 to that in 2013?
Ensure brevity in your answer.  0.87. What is the ratio of the Balance of Payment (as % of service exports) of Travel services in 2011 to that in 2013?
Ensure brevity in your answer.  1.02. What is the ratio of the Balance of Payment (as % of service exports) in ICT services in 2011 to that in 2013?
Your answer should be compact. 1.38. What is the ratio of the Balance of Payment (as % of service exports) of Transport services in 2012 to that in 2013?
Your answer should be very brief. 0.87. What is the ratio of the Balance of Payment (as % of service exports) of Travel services in 2012 to that in 2013?
Give a very brief answer. 1.08. What is the ratio of the Balance of Payment (as % of service exports) of ICT services in 2012 to that in 2013?
Ensure brevity in your answer.  1.11. What is the difference between the highest and the second highest Balance of Payment (as % of service exports) in Transport services?
Your response must be concise. 1.35. What is the difference between the highest and the second highest Balance of Payment (as % of service exports) of Travel services?
Offer a terse response. 1.32. What is the difference between the highest and the second highest Balance of Payment (as % of service exports) of ICT services?
Offer a terse response. 2.76. What is the difference between the highest and the lowest Balance of Payment (as % of service exports) of Transport services?
Make the answer very short. 17.2. What is the difference between the highest and the lowest Balance of Payment (as % of service exports) in Travel services?
Your answer should be compact. 13.11. What is the difference between the highest and the lowest Balance of Payment (as % of service exports) of ICT services?
Make the answer very short. 5.01. 